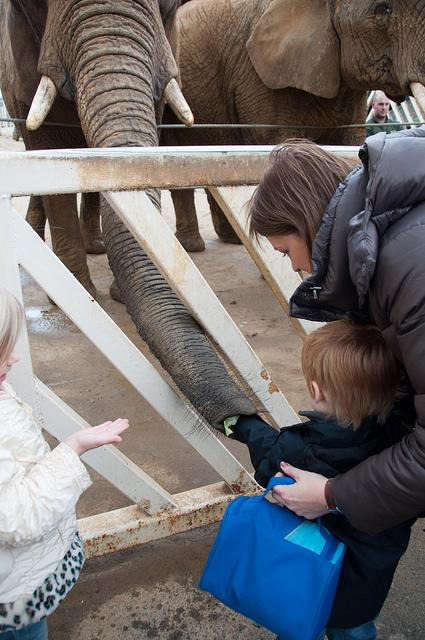Where are the elephants behind held? Please explain your reasoning. in zoo. These animals come from the wild and have to be showcased in a safe setting. 